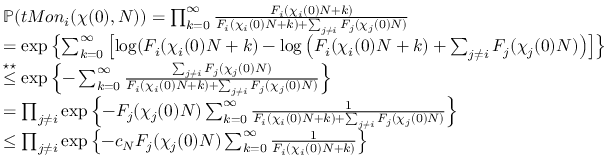Convert formula to latex. <formula><loc_0><loc_0><loc_500><loc_500>\begin{array} { r l } & { \mathbb { P } ( t M o n _ { i } ( \chi ( 0 ) , N ) ) = \prod _ { k = 0 } ^ { \infty } \frac { F _ { i } ( \chi _ { i } ( 0 ) N + k ) } { F _ { i } ( \chi _ { i } ( 0 ) N + k ) + \sum _ { j \ne i } F _ { j } ( \chi _ { j } ( 0 ) N ) } } \\ & { = \exp \left \{ \sum _ { k = 0 } ^ { \infty } \left [ \log ( F _ { i } ( \chi _ { i } ( 0 ) N + k ) - \log \left ( F _ { i } ( \chi _ { i } ( 0 ) N + k ) + \sum _ { j \ne i } F _ { j } ( \chi _ { j } ( 0 ) N ) \right ) \right ] \right \} } \\ & { \overset { ^ { * } ^ { * } } { \leq } \exp \left \{ - \sum _ { k = 0 } ^ { \infty } \frac { \sum _ { j \ne i } F _ { j } ( \chi _ { j } ( 0 ) N ) } { F _ { i } ( \chi _ { i } ( 0 ) N + k ) + \sum _ { j \ne i } F _ { j } ( \chi _ { j } ( 0 ) N ) } \right \} } \\ & { = \prod _ { j \ne i } \exp \left \{ - F _ { j } ( \chi _ { j } ( 0 ) N ) \sum _ { k = 0 } ^ { \infty } \frac { 1 } { F _ { i } ( \chi _ { i } ( 0 ) N + k ) + \sum _ { j \ne i } F _ { j } ( \chi _ { j } ( 0 ) N ) } \right \} } \\ & { \leq \prod _ { j \ne i } \exp \left \{ - c _ { N } F _ { j } ( \chi _ { j } ( 0 ) N ) \sum _ { k = 0 } ^ { \infty } \frac { 1 } { F _ { i } ( \chi _ { i } ( 0 ) N + k ) } \right \} } \end{array}</formula> 